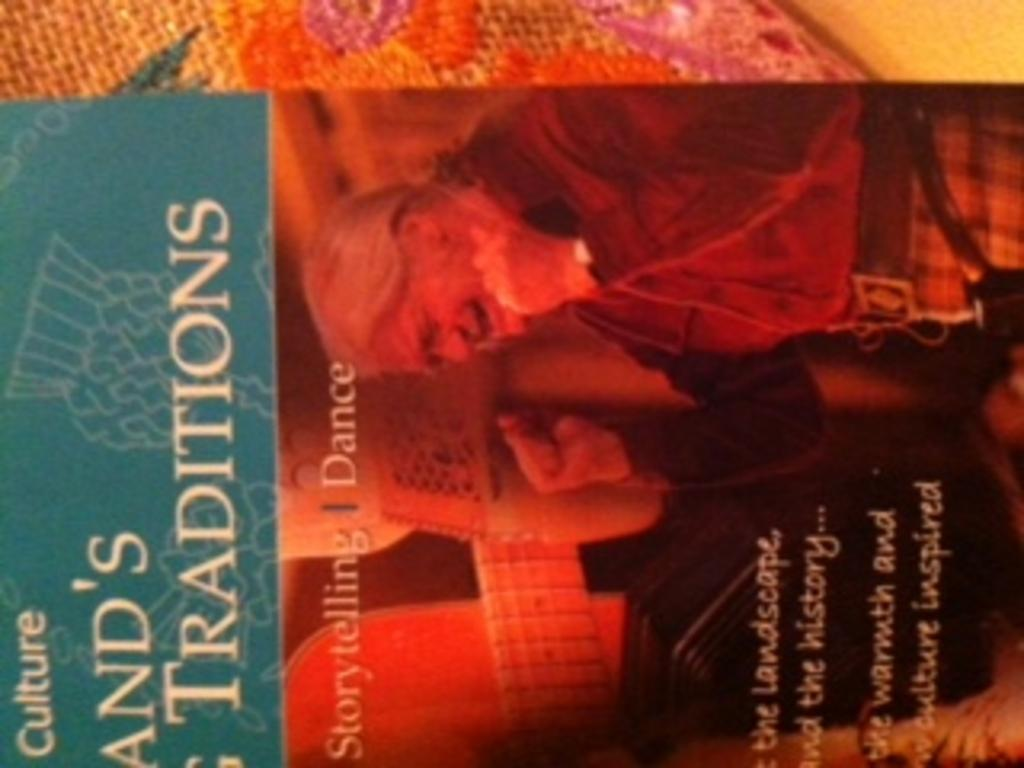<image>
Write a terse but informative summary of the picture. The word culture appears on the top of a book cover. 